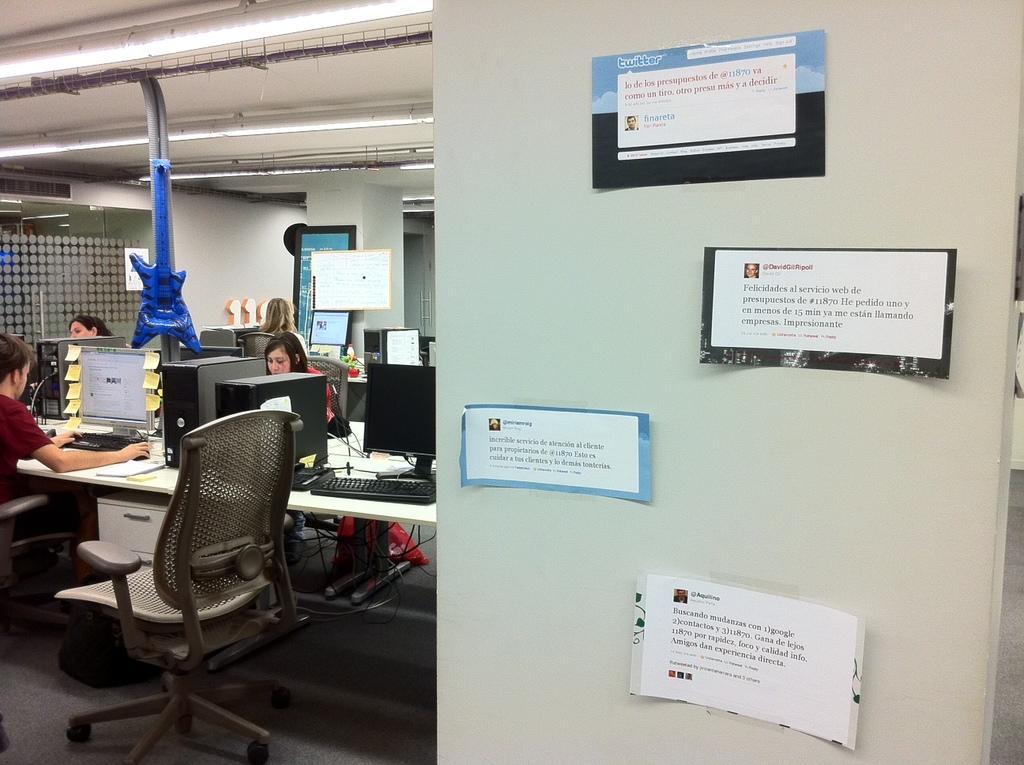Describe this image in one or two sentences. In this image we can see some people sitting on the chairs beside a table containing some computers. We can also see an empty chair, wires, a cupboard and some papers pasted on a wall. On the backside we can see a paper guitar and a roof with some ceiling lights. 